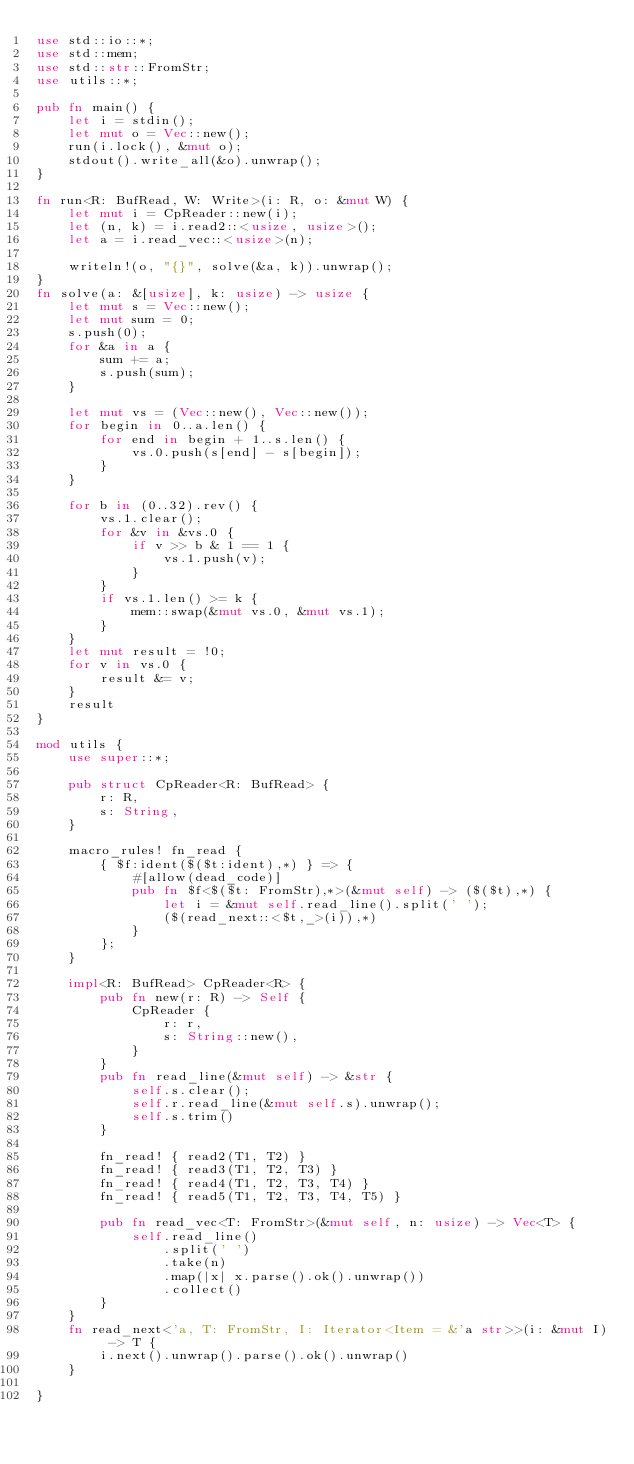Convert code to text. <code><loc_0><loc_0><loc_500><loc_500><_Rust_>use std::io::*;
use std::mem;
use std::str::FromStr;
use utils::*;

pub fn main() {
    let i = stdin();
    let mut o = Vec::new();
    run(i.lock(), &mut o);
    stdout().write_all(&o).unwrap();
}

fn run<R: BufRead, W: Write>(i: R, o: &mut W) {
    let mut i = CpReader::new(i);
    let (n, k) = i.read2::<usize, usize>();
    let a = i.read_vec::<usize>(n);

    writeln!(o, "{}", solve(&a, k)).unwrap();
}
fn solve(a: &[usize], k: usize) -> usize {
    let mut s = Vec::new();
    let mut sum = 0;
    s.push(0);
    for &a in a {
        sum += a;
        s.push(sum);
    }

    let mut vs = (Vec::new(), Vec::new());
    for begin in 0..a.len() {
        for end in begin + 1..s.len() {
            vs.0.push(s[end] - s[begin]);
        }
    }

    for b in (0..32).rev() {
        vs.1.clear();
        for &v in &vs.0 {
            if v >> b & 1 == 1 {
                vs.1.push(v);
            }
        }
        if vs.1.len() >= k {
            mem::swap(&mut vs.0, &mut vs.1);
        }
    }
    let mut result = !0;
    for v in vs.0 {
        result &= v;
    }
    result
}

mod utils {
    use super::*;

    pub struct CpReader<R: BufRead> {
        r: R,
        s: String,
    }

    macro_rules! fn_read {
        { $f:ident($($t:ident),*) } => {
            #[allow(dead_code)]
            pub fn $f<$($t: FromStr),*>(&mut self) -> ($($t),*) {
                let i = &mut self.read_line().split(' ');
                ($(read_next::<$t,_>(i)),*)
            }
        };
    }

    impl<R: BufRead> CpReader<R> {
        pub fn new(r: R) -> Self {
            CpReader {
                r: r,
                s: String::new(),
            }
        }
        pub fn read_line(&mut self) -> &str {
            self.s.clear();
            self.r.read_line(&mut self.s).unwrap();
            self.s.trim()
        }

        fn_read! { read2(T1, T2) }
        fn_read! { read3(T1, T2, T3) }
        fn_read! { read4(T1, T2, T3, T4) }
        fn_read! { read5(T1, T2, T3, T4, T5) }

        pub fn read_vec<T: FromStr>(&mut self, n: usize) -> Vec<T> {
            self.read_line()
                .split(' ')
                .take(n)
                .map(|x| x.parse().ok().unwrap())
                .collect()
        }
    }
    fn read_next<'a, T: FromStr, I: Iterator<Item = &'a str>>(i: &mut I) -> T {
        i.next().unwrap().parse().ok().unwrap()
    }

}
</code> 